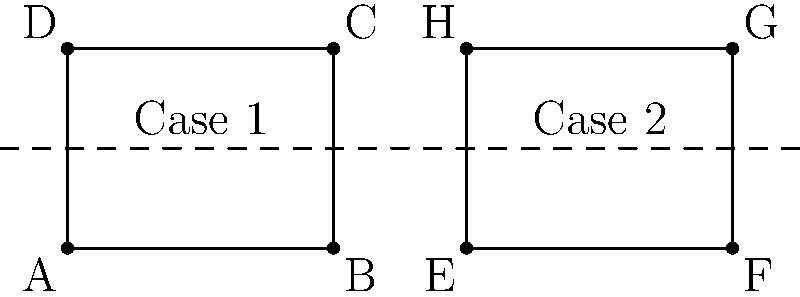You are designing two matching display cases for a pair of valuable antique vases. The cases are rectangular and have the same dimensions. Case 1 has vertices A(0,0), B(4,0), C(4,3), and D(0,3). Case 2 is a reflection of Case 1 across the line x = 5. What are the coordinates of vertex G in Case 2? To find the coordinates of vertex G in Case 2, we need to follow these steps:

1) First, identify the corresponding point in Case 1. Vertex G in Case 2 corresponds to vertex C in Case 1.

2) The coordinates of C in Case 1 are (4,3).

3) The line of reflection is x = 5. This means that any point (x,y) will be reflected to (10-x,y).

4) To reflect point C(4,3) across the line x = 5:
   - The x-coordinate: 10 - 4 = 6
   - The y-coordinate remains the same: 3

5) Therefore, the reflected point G has coordinates (6,3).

6) To verify:
   - The distance from C to the line of reflection (x = 5) is 1 unit.
   - The distance from G to the line of reflection is also 1 unit.
   - The y-coordinate remains unchanged.

Thus, the reflection of C(4,3) across the line x = 5 is G(6,3).
Answer: (6,3) 